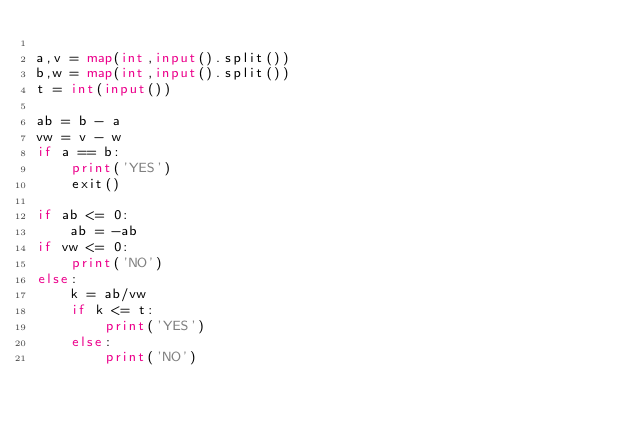Convert code to text. <code><loc_0><loc_0><loc_500><loc_500><_Python_>
a,v = map(int,input().split())
b,w = map(int,input().split())
t = int(input())

ab = b - a
vw = v - w
if a == b:
    print('YES')
    exit()

if ab <= 0:
    ab = -ab
if vw <= 0:
    print('NO')
else:
    k = ab/vw
    if k <= t:
        print('YES')
    else:
        print('NO')





</code> 